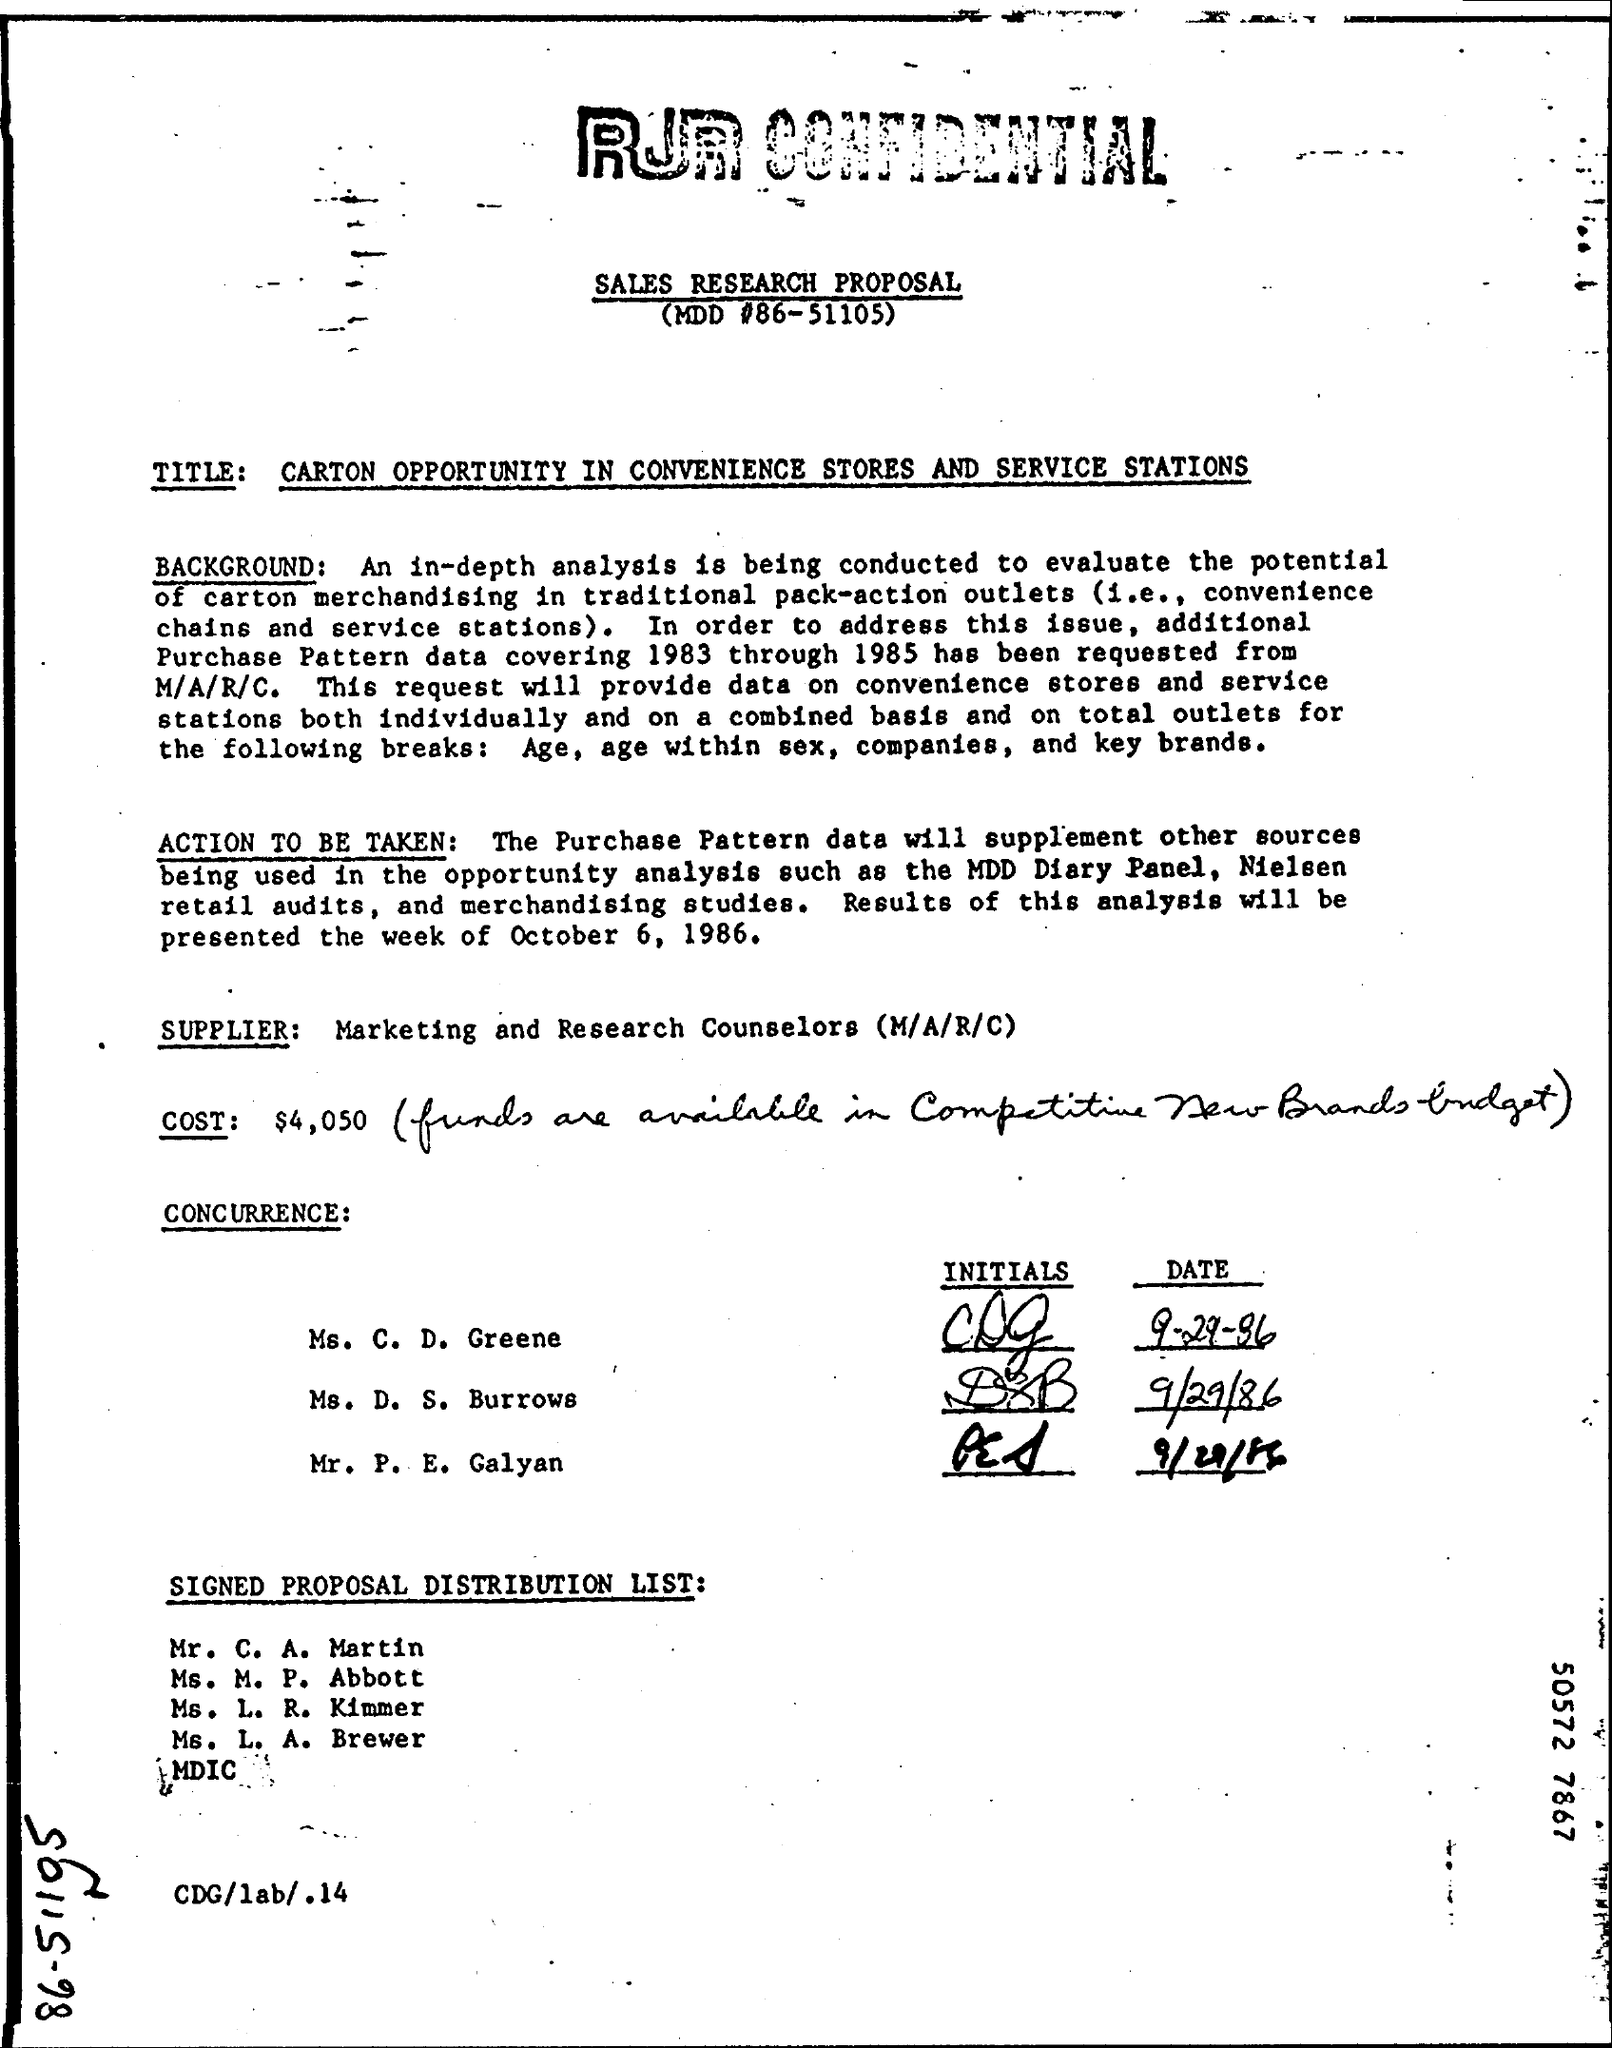Outline some significant characteristics in this image. The value of cost, as mentioned in the given proposal, is $4,050. 